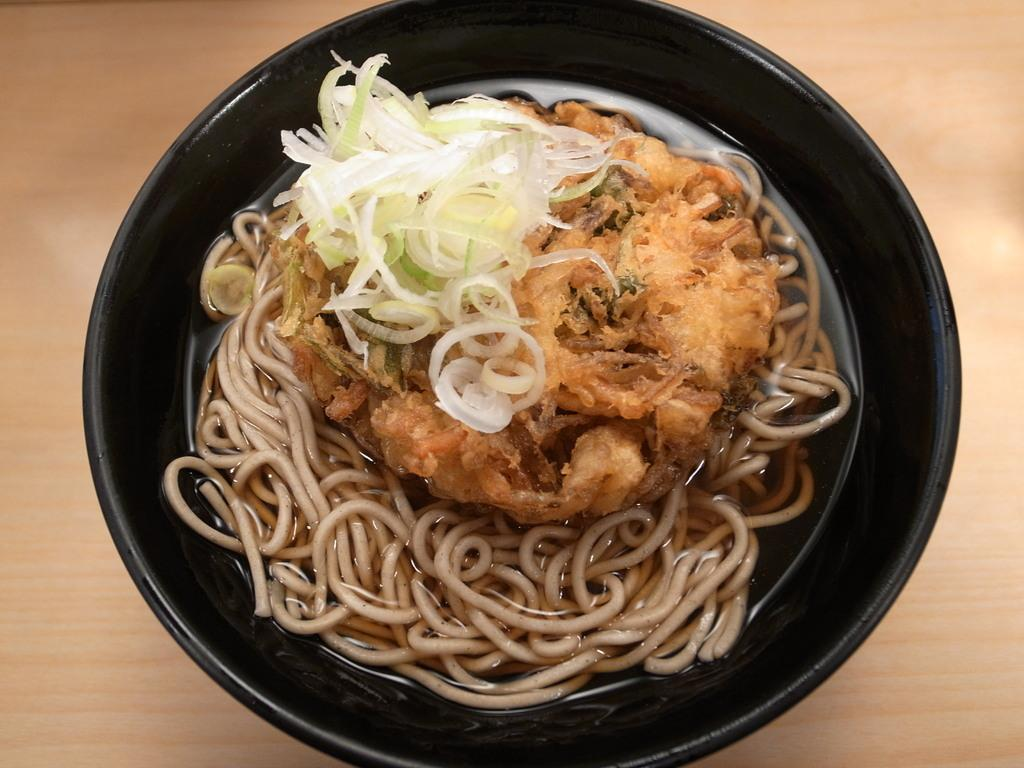What type of table is in the image? There is a wooden table in the image. What is on top of the table? There is a bowl on the table. What is inside the bowl? The bowl contains Chinese noodles. Where is the plastic lunchroom located in the image? There is no plastic lunchroom present in the image. What form does the Chinese noodles take in the image? The Chinese noodles are in the form of noodles inside a bowl, as described in the facts. 